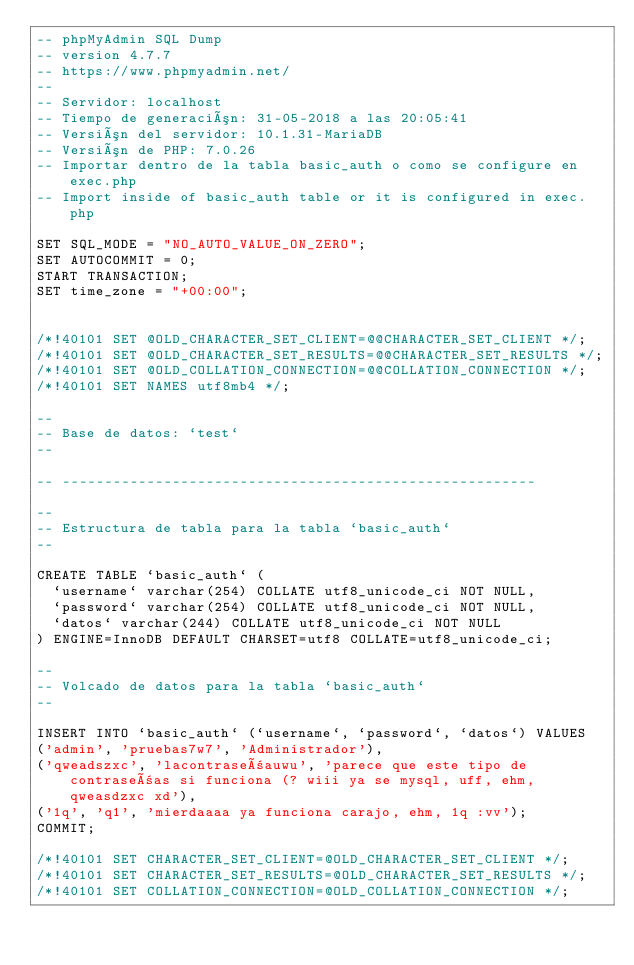Convert code to text. <code><loc_0><loc_0><loc_500><loc_500><_SQL_>-- phpMyAdmin SQL Dump
-- version 4.7.7
-- https://www.phpmyadmin.net/
--
-- Servidor: localhost
-- Tiempo de generación: 31-05-2018 a las 20:05:41
-- Versión del servidor: 10.1.31-MariaDB
-- Versión de PHP: 7.0.26
-- Importar dentro de la tabla basic_auth o como se configure en exec.php
-- Import inside of basic_auth table or it is configured in exec.php

SET SQL_MODE = "NO_AUTO_VALUE_ON_ZERO";
SET AUTOCOMMIT = 0;
START TRANSACTION;
SET time_zone = "+00:00";


/*!40101 SET @OLD_CHARACTER_SET_CLIENT=@@CHARACTER_SET_CLIENT */;
/*!40101 SET @OLD_CHARACTER_SET_RESULTS=@@CHARACTER_SET_RESULTS */;
/*!40101 SET @OLD_COLLATION_CONNECTION=@@COLLATION_CONNECTION */;
/*!40101 SET NAMES utf8mb4 */;

--
-- Base de datos: `test`
--

-- --------------------------------------------------------

--
-- Estructura de tabla para la tabla `basic_auth`
--

CREATE TABLE `basic_auth` (
  `username` varchar(254) COLLATE utf8_unicode_ci NOT NULL,
  `password` varchar(254) COLLATE utf8_unicode_ci NOT NULL,
  `datos` varchar(244) COLLATE utf8_unicode_ci NOT NULL
) ENGINE=InnoDB DEFAULT CHARSET=utf8 COLLATE=utf8_unicode_ci;

--
-- Volcado de datos para la tabla `basic_auth`
--

INSERT INTO `basic_auth` (`username`, `password`, `datos`) VALUES
('admin', 'pruebas7w7', 'Administrador'),
('qweadszxc', 'lacontraseñauwu', 'parece que este tipo de contraseñas si funciona (? wiii ya se mysql, uff, ehm, qweasdzxc xd'),
('1q', 'q1', 'mierdaaaa ya funciona carajo, ehm, 1q :vv');
COMMIT;

/*!40101 SET CHARACTER_SET_CLIENT=@OLD_CHARACTER_SET_CLIENT */;
/*!40101 SET CHARACTER_SET_RESULTS=@OLD_CHARACTER_SET_RESULTS */;
/*!40101 SET COLLATION_CONNECTION=@OLD_COLLATION_CONNECTION */;
</code> 